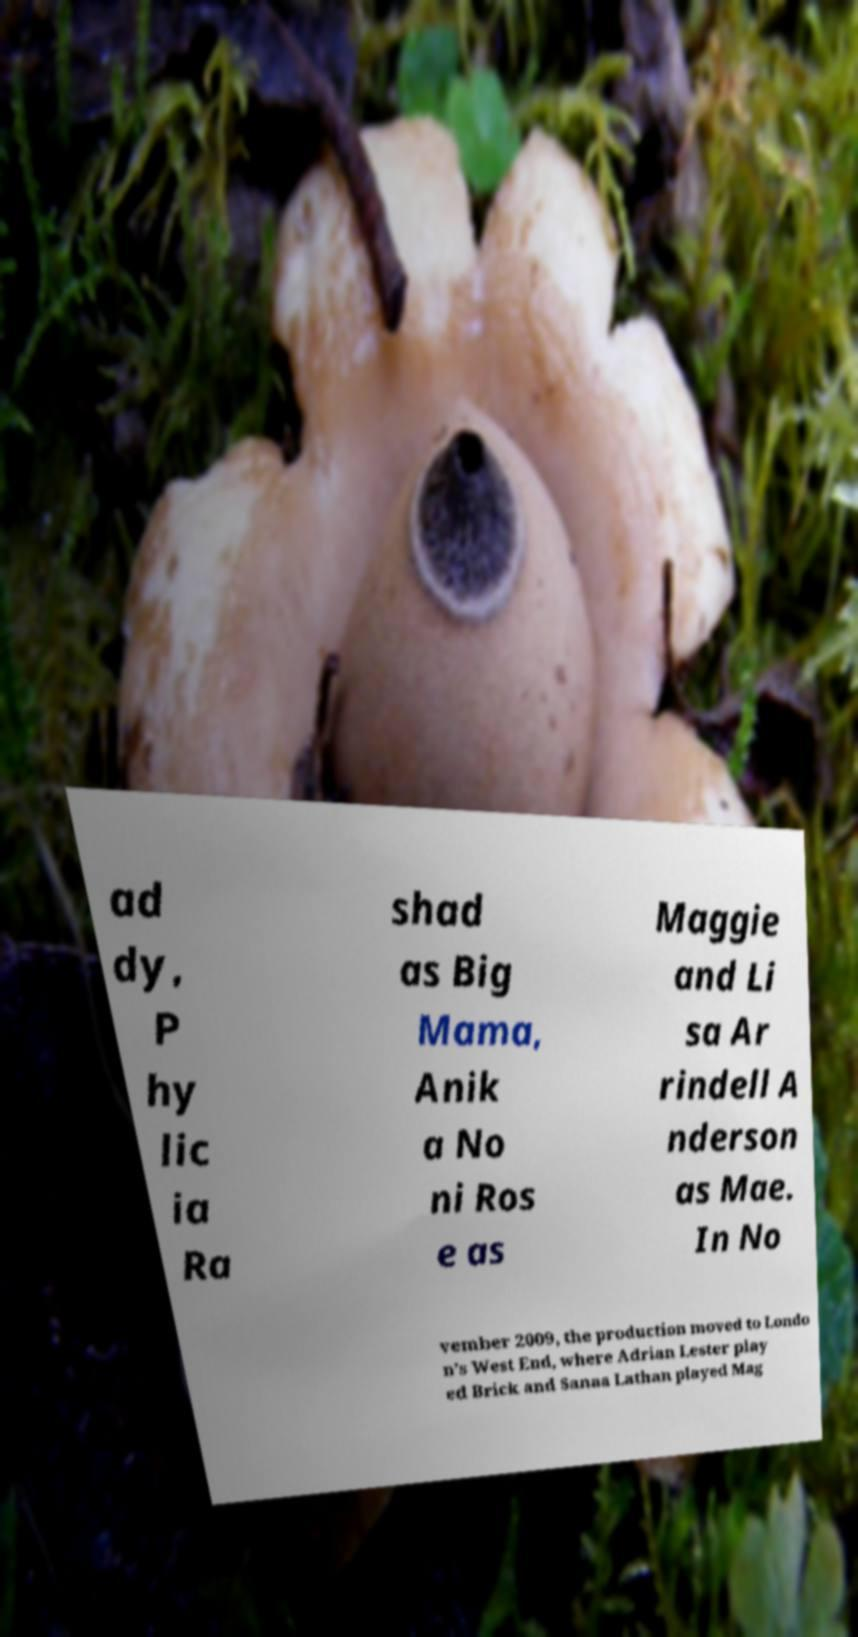Please identify and transcribe the text found in this image. ad dy, P hy lic ia Ra shad as Big Mama, Anik a No ni Ros e as Maggie and Li sa Ar rindell A nderson as Mae. In No vember 2009, the production moved to Londo n's West End, where Adrian Lester play ed Brick and Sanaa Lathan played Mag 